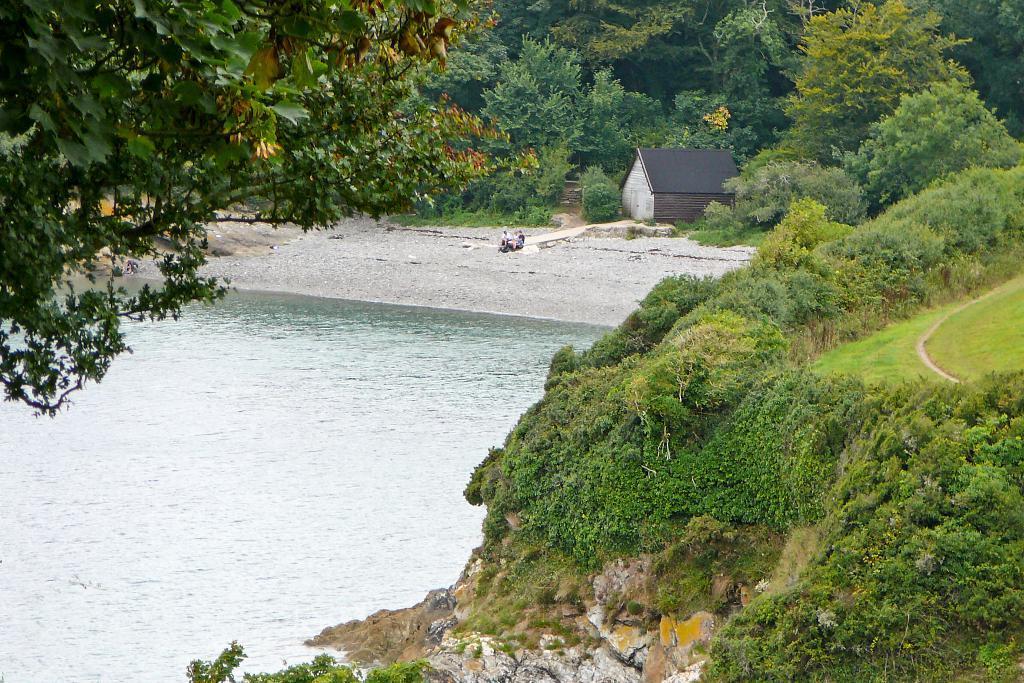Can you describe this image briefly? In this picture there is water on the left side of the image and there is greenery around the area of the image, there is a shed at the top side of the image. 